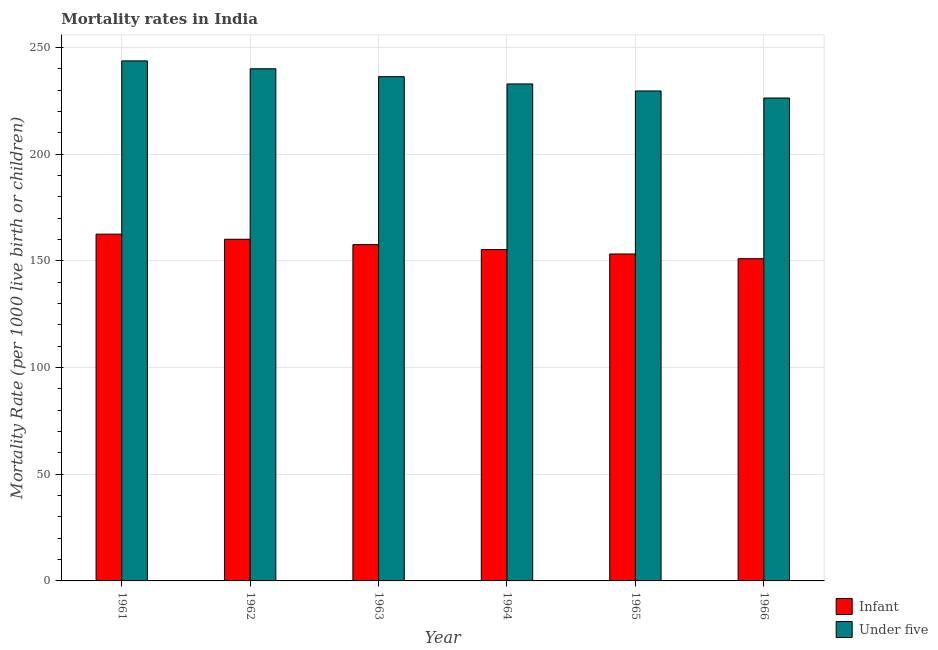How many different coloured bars are there?
Provide a succinct answer. 2. Are the number of bars on each tick of the X-axis equal?
Offer a very short reply. Yes. What is the label of the 5th group of bars from the left?
Keep it short and to the point. 1965. What is the infant mortality rate in 1963?
Keep it short and to the point. 157.6. Across all years, what is the maximum under-5 mortality rate?
Provide a short and direct response. 243.7. Across all years, what is the minimum infant mortality rate?
Offer a terse response. 151. In which year was the under-5 mortality rate maximum?
Your response must be concise. 1961. In which year was the infant mortality rate minimum?
Provide a succinct answer. 1966. What is the total under-5 mortality rate in the graph?
Your answer should be very brief. 1408.8. What is the difference between the infant mortality rate in 1963 and that in 1965?
Provide a short and direct response. 4.4. What is the difference between the infant mortality rate in 1962 and the under-5 mortality rate in 1966?
Offer a very short reply. 9.1. What is the average under-5 mortality rate per year?
Provide a short and direct response. 234.8. In the year 1964, what is the difference between the under-5 mortality rate and infant mortality rate?
Offer a very short reply. 0. What is the ratio of the infant mortality rate in 1963 to that in 1964?
Keep it short and to the point. 1.01. Is the difference between the infant mortality rate in 1963 and 1964 greater than the difference between the under-5 mortality rate in 1963 and 1964?
Keep it short and to the point. No. What is the difference between the highest and the second highest under-5 mortality rate?
Make the answer very short. 3.7. What is the difference between the highest and the lowest under-5 mortality rate?
Your answer should be very brief. 17.4. In how many years, is the under-5 mortality rate greater than the average under-5 mortality rate taken over all years?
Your answer should be compact. 3. Is the sum of the under-5 mortality rate in 1962 and 1963 greater than the maximum infant mortality rate across all years?
Your response must be concise. Yes. What does the 1st bar from the left in 1964 represents?
Offer a very short reply. Infant. What does the 2nd bar from the right in 1961 represents?
Your response must be concise. Infant. What is the difference between two consecutive major ticks on the Y-axis?
Offer a very short reply. 50. Are the values on the major ticks of Y-axis written in scientific E-notation?
Offer a terse response. No. Does the graph contain grids?
Offer a very short reply. Yes. How many legend labels are there?
Give a very brief answer. 2. What is the title of the graph?
Provide a succinct answer. Mortality rates in India. What is the label or title of the X-axis?
Offer a terse response. Year. What is the label or title of the Y-axis?
Your answer should be compact. Mortality Rate (per 1000 live birth or children). What is the Mortality Rate (per 1000 live birth or children) in Infant in 1961?
Give a very brief answer. 162.5. What is the Mortality Rate (per 1000 live birth or children) in Under five in 1961?
Your answer should be compact. 243.7. What is the Mortality Rate (per 1000 live birth or children) of Infant in 1962?
Offer a terse response. 160.1. What is the Mortality Rate (per 1000 live birth or children) of Under five in 1962?
Your answer should be very brief. 240. What is the Mortality Rate (per 1000 live birth or children) of Infant in 1963?
Your answer should be very brief. 157.6. What is the Mortality Rate (per 1000 live birth or children) in Under five in 1963?
Provide a succinct answer. 236.3. What is the Mortality Rate (per 1000 live birth or children) of Infant in 1964?
Keep it short and to the point. 155.3. What is the Mortality Rate (per 1000 live birth or children) in Under five in 1964?
Offer a very short reply. 232.9. What is the Mortality Rate (per 1000 live birth or children) of Infant in 1965?
Offer a terse response. 153.2. What is the Mortality Rate (per 1000 live birth or children) in Under five in 1965?
Offer a very short reply. 229.6. What is the Mortality Rate (per 1000 live birth or children) of Infant in 1966?
Your answer should be very brief. 151. What is the Mortality Rate (per 1000 live birth or children) of Under five in 1966?
Offer a terse response. 226.3. Across all years, what is the maximum Mortality Rate (per 1000 live birth or children) of Infant?
Ensure brevity in your answer.  162.5. Across all years, what is the maximum Mortality Rate (per 1000 live birth or children) of Under five?
Your answer should be compact. 243.7. Across all years, what is the minimum Mortality Rate (per 1000 live birth or children) in Infant?
Your response must be concise. 151. Across all years, what is the minimum Mortality Rate (per 1000 live birth or children) in Under five?
Your response must be concise. 226.3. What is the total Mortality Rate (per 1000 live birth or children) in Infant in the graph?
Keep it short and to the point. 939.7. What is the total Mortality Rate (per 1000 live birth or children) in Under five in the graph?
Provide a short and direct response. 1408.8. What is the difference between the Mortality Rate (per 1000 live birth or children) in Infant in 1961 and that in 1962?
Offer a very short reply. 2.4. What is the difference between the Mortality Rate (per 1000 live birth or children) in Infant in 1961 and that in 1963?
Provide a succinct answer. 4.9. What is the difference between the Mortality Rate (per 1000 live birth or children) of Under five in 1961 and that in 1963?
Keep it short and to the point. 7.4. What is the difference between the Mortality Rate (per 1000 live birth or children) of Under five in 1961 and that in 1964?
Give a very brief answer. 10.8. What is the difference between the Mortality Rate (per 1000 live birth or children) of Infant in 1961 and that in 1965?
Ensure brevity in your answer.  9.3. What is the difference between the Mortality Rate (per 1000 live birth or children) of Under five in 1961 and that in 1965?
Give a very brief answer. 14.1. What is the difference between the Mortality Rate (per 1000 live birth or children) of Infant in 1961 and that in 1966?
Your response must be concise. 11.5. What is the difference between the Mortality Rate (per 1000 live birth or children) in Under five in 1961 and that in 1966?
Keep it short and to the point. 17.4. What is the difference between the Mortality Rate (per 1000 live birth or children) in Infant in 1962 and that in 1963?
Ensure brevity in your answer.  2.5. What is the difference between the Mortality Rate (per 1000 live birth or children) of Under five in 1962 and that in 1964?
Offer a very short reply. 7.1. What is the difference between the Mortality Rate (per 1000 live birth or children) in Infant in 1962 and that in 1965?
Keep it short and to the point. 6.9. What is the difference between the Mortality Rate (per 1000 live birth or children) of Infant in 1962 and that in 1966?
Provide a short and direct response. 9.1. What is the difference between the Mortality Rate (per 1000 live birth or children) of Under five in 1963 and that in 1966?
Give a very brief answer. 10. What is the difference between the Mortality Rate (per 1000 live birth or children) of Under five in 1964 and that in 1965?
Offer a very short reply. 3.3. What is the difference between the Mortality Rate (per 1000 live birth or children) of Infant in 1964 and that in 1966?
Offer a terse response. 4.3. What is the difference between the Mortality Rate (per 1000 live birth or children) in Under five in 1964 and that in 1966?
Ensure brevity in your answer.  6.6. What is the difference between the Mortality Rate (per 1000 live birth or children) of Infant in 1961 and the Mortality Rate (per 1000 live birth or children) of Under five in 1962?
Keep it short and to the point. -77.5. What is the difference between the Mortality Rate (per 1000 live birth or children) in Infant in 1961 and the Mortality Rate (per 1000 live birth or children) in Under five in 1963?
Provide a succinct answer. -73.8. What is the difference between the Mortality Rate (per 1000 live birth or children) in Infant in 1961 and the Mortality Rate (per 1000 live birth or children) in Under five in 1964?
Offer a terse response. -70.4. What is the difference between the Mortality Rate (per 1000 live birth or children) of Infant in 1961 and the Mortality Rate (per 1000 live birth or children) of Under five in 1965?
Make the answer very short. -67.1. What is the difference between the Mortality Rate (per 1000 live birth or children) in Infant in 1961 and the Mortality Rate (per 1000 live birth or children) in Under five in 1966?
Make the answer very short. -63.8. What is the difference between the Mortality Rate (per 1000 live birth or children) of Infant in 1962 and the Mortality Rate (per 1000 live birth or children) of Under five in 1963?
Make the answer very short. -76.2. What is the difference between the Mortality Rate (per 1000 live birth or children) of Infant in 1962 and the Mortality Rate (per 1000 live birth or children) of Under five in 1964?
Provide a short and direct response. -72.8. What is the difference between the Mortality Rate (per 1000 live birth or children) of Infant in 1962 and the Mortality Rate (per 1000 live birth or children) of Under five in 1965?
Offer a very short reply. -69.5. What is the difference between the Mortality Rate (per 1000 live birth or children) of Infant in 1962 and the Mortality Rate (per 1000 live birth or children) of Under five in 1966?
Your answer should be compact. -66.2. What is the difference between the Mortality Rate (per 1000 live birth or children) of Infant in 1963 and the Mortality Rate (per 1000 live birth or children) of Under five in 1964?
Offer a terse response. -75.3. What is the difference between the Mortality Rate (per 1000 live birth or children) in Infant in 1963 and the Mortality Rate (per 1000 live birth or children) in Under five in 1965?
Your answer should be very brief. -72. What is the difference between the Mortality Rate (per 1000 live birth or children) in Infant in 1963 and the Mortality Rate (per 1000 live birth or children) in Under five in 1966?
Provide a short and direct response. -68.7. What is the difference between the Mortality Rate (per 1000 live birth or children) in Infant in 1964 and the Mortality Rate (per 1000 live birth or children) in Under five in 1965?
Make the answer very short. -74.3. What is the difference between the Mortality Rate (per 1000 live birth or children) in Infant in 1964 and the Mortality Rate (per 1000 live birth or children) in Under five in 1966?
Your response must be concise. -71. What is the difference between the Mortality Rate (per 1000 live birth or children) of Infant in 1965 and the Mortality Rate (per 1000 live birth or children) of Under five in 1966?
Keep it short and to the point. -73.1. What is the average Mortality Rate (per 1000 live birth or children) of Infant per year?
Keep it short and to the point. 156.62. What is the average Mortality Rate (per 1000 live birth or children) in Under five per year?
Your response must be concise. 234.8. In the year 1961, what is the difference between the Mortality Rate (per 1000 live birth or children) of Infant and Mortality Rate (per 1000 live birth or children) of Under five?
Give a very brief answer. -81.2. In the year 1962, what is the difference between the Mortality Rate (per 1000 live birth or children) of Infant and Mortality Rate (per 1000 live birth or children) of Under five?
Offer a terse response. -79.9. In the year 1963, what is the difference between the Mortality Rate (per 1000 live birth or children) in Infant and Mortality Rate (per 1000 live birth or children) in Under five?
Offer a very short reply. -78.7. In the year 1964, what is the difference between the Mortality Rate (per 1000 live birth or children) in Infant and Mortality Rate (per 1000 live birth or children) in Under five?
Provide a succinct answer. -77.6. In the year 1965, what is the difference between the Mortality Rate (per 1000 live birth or children) of Infant and Mortality Rate (per 1000 live birth or children) of Under five?
Your answer should be compact. -76.4. In the year 1966, what is the difference between the Mortality Rate (per 1000 live birth or children) of Infant and Mortality Rate (per 1000 live birth or children) of Under five?
Offer a terse response. -75.3. What is the ratio of the Mortality Rate (per 1000 live birth or children) of Infant in 1961 to that in 1962?
Provide a succinct answer. 1.01. What is the ratio of the Mortality Rate (per 1000 live birth or children) in Under five in 1961 to that in 1962?
Your response must be concise. 1.02. What is the ratio of the Mortality Rate (per 1000 live birth or children) in Infant in 1961 to that in 1963?
Give a very brief answer. 1.03. What is the ratio of the Mortality Rate (per 1000 live birth or children) in Under five in 1961 to that in 1963?
Ensure brevity in your answer.  1.03. What is the ratio of the Mortality Rate (per 1000 live birth or children) in Infant in 1961 to that in 1964?
Keep it short and to the point. 1.05. What is the ratio of the Mortality Rate (per 1000 live birth or children) in Under five in 1961 to that in 1964?
Make the answer very short. 1.05. What is the ratio of the Mortality Rate (per 1000 live birth or children) in Infant in 1961 to that in 1965?
Your answer should be compact. 1.06. What is the ratio of the Mortality Rate (per 1000 live birth or children) of Under five in 1961 to that in 1965?
Provide a short and direct response. 1.06. What is the ratio of the Mortality Rate (per 1000 live birth or children) in Infant in 1961 to that in 1966?
Provide a short and direct response. 1.08. What is the ratio of the Mortality Rate (per 1000 live birth or children) in Under five in 1961 to that in 1966?
Your answer should be compact. 1.08. What is the ratio of the Mortality Rate (per 1000 live birth or children) in Infant in 1962 to that in 1963?
Your response must be concise. 1.02. What is the ratio of the Mortality Rate (per 1000 live birth or children) of Under five in 1962 to that in 1963?
Ensure brevity in your answer.  1.02. What is the ratio of the Mortality Rate (per 1000 live birth or children) of Infant in 1962 to that in 1964?
Offer a terse response. 1.03. What is the ratio of the Mortality Rate (per 1000 live birth or children) in Under five in 1962 to that in 1964?
Offer a terse response. 1.03. What is the ratio of the Mortality Rate (per 1000 live birth or children) of Infant in 1962 to that in 1965?
Offer a very short reply. 1.04. What is the ratio of the Mortality Rate (per 1000 live birth or children) in Under five in 1962 to that in 1965?
Your answer should be compact. 1.05. What is the ratio of the Mortality Rate (per 1000 live birth or children) of Infant in 1962 to that in 1966?
Make the answer very short. 1.06. What is the ratio of the Mortality Rate (per 1000 live birth or children) of Under five in 1962 to that in 1966?
Your answer should be very brief. 1.06. What is the ratio of the Mortality Rate (per 1000 live birth or children) of Infant in 1963 to that in 1964?
Ensure brevity in your answer.  1.01. What is the ratio of the Mortality Rate (per 1000 live birth or children) in Under five in 1963 to that in 1964?
Make the answer very short. 1.01. What is the ratio of the Mortality Rate (per 1000 live birth or children) in Infant in 1963 to that in 1965?
Offer a terse response. 1.03. What is the ratio of the Mortality Rate (per 1000 live birth or children) in Under five in 1963 to that in 1965?
Your response must be concise. 1.03. What is the ratio of the Mortality Rate (per 1000 live birth or children) in Infant in 1963 to that in 1966?
Provide a succinct answer. 1.04. What is the ratio of the Mortality Rate (per 1000 live birth or children) in Under five in 1963 to that in 1966?
Offer a very short reply. 1.04. What is the ratio of the Mortality Rate (per 1000 live birth or children) in Infant in 1964 to that in 1965?
Your response must be concise. 1.01. What is the ratio of the Mortality Rate (per 1000 live birth or children) in Under five in 1964 to that in 1965?
Ensure brevity in your answer.  1.01. What is the ratio of the Mortality Rate (per 1000 live birth or children) of Infant in 1964 to that in 1966?
Provide a succinct answer. 1.03. What is the ratio of the Mortality Rate (per 1000 live birth or children) of Under five in 1964 to that in 1966?
Your answer should be very brief. 1.03. What is the ratio of the Mortality Rate (per 1000 live birth or children) of Infant in 1965 to that in 1966?
Offer a very short reply. 1.01. What is the ratio of the Mortality Rate (per 1000 live birth or children) of Under five in 1965 to that in 1966?
Give a very brief answer. 1.01. What is the difference between the highest and the second highest Mortality Rate (per 1000 live birth or children) in Under five?
Your answer should be very brief. 3.7. 